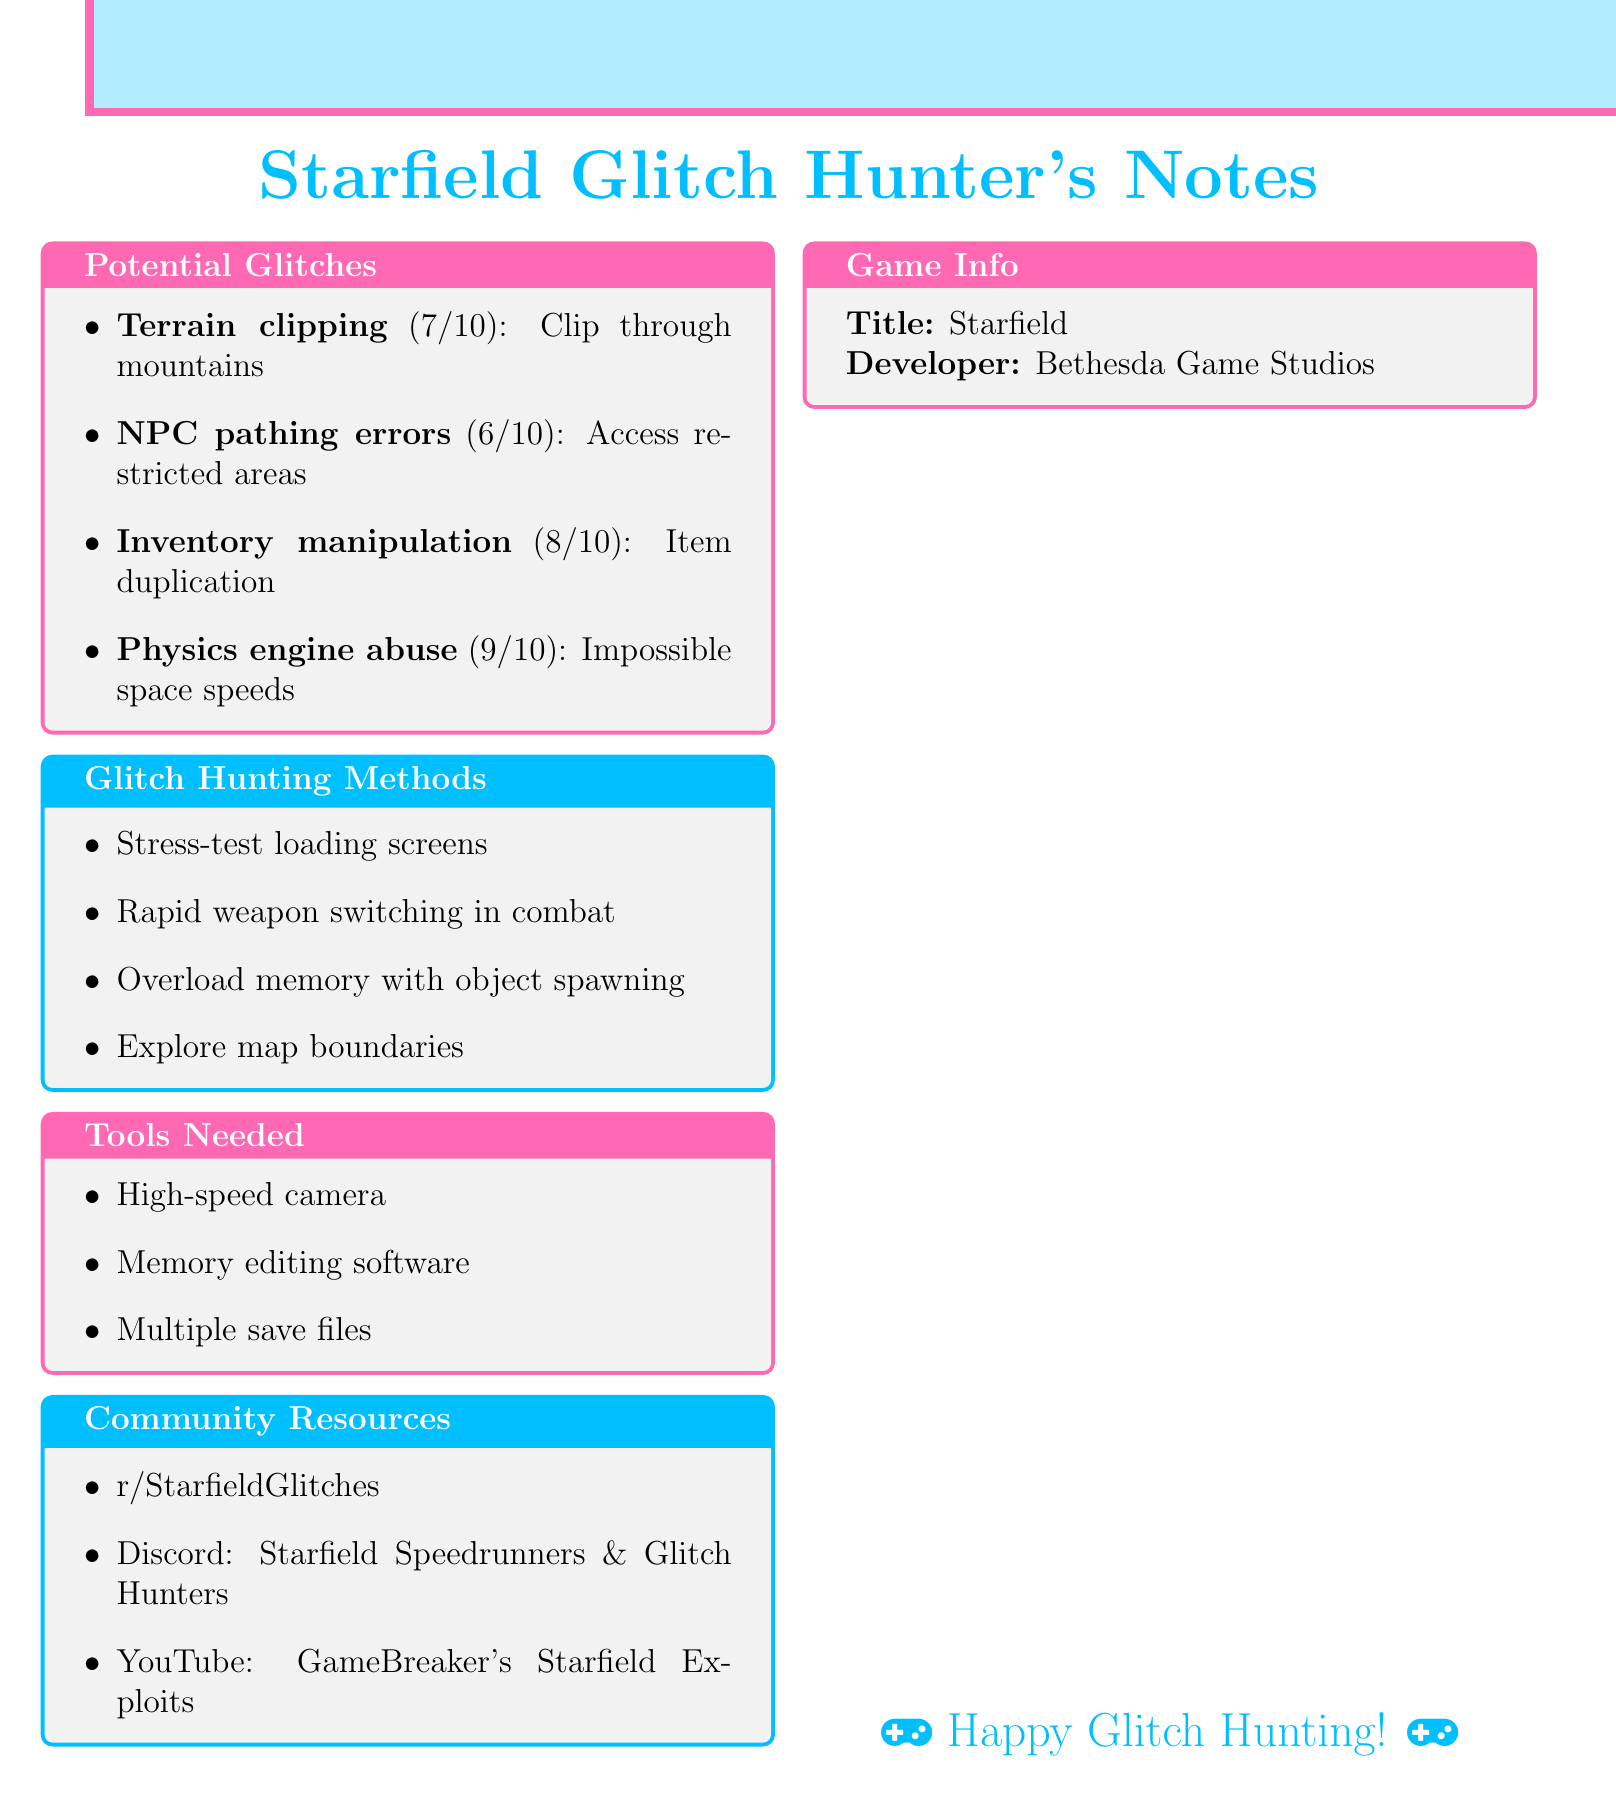what is the game title? The game title is mentioned at the beginning of the document as "Starfield".
Answer: Starfield who is the developer of the game? The developer of the game is explicitly stated in the document as "Bethesda Game Studios".
Answer: Bethesda Game Studios how many potential glitches are listed? The total number of potential glitches is counted from the list provided in the document.
Answer: 4 what is the exploitability rating for inventory manipulation? The exploitability rating is presented as a score next to each glitch in the document.
Answer: 8 which community resource is a subreddit? The document lists several community resources, and one of them is a subreddit mentioned explicitly.
Answer: r/StarfieldGlitches what method involves testing loading screens? The document lists various glitch hunting methods, one of which involves stress-testing loading screens.
Answer: Stress-test loading screens what tool is recommended for frame-by-frame analysis? The tools needed to assist with glitch hunting include a specific device for detailed observation mentioned in the document.
Answer: High-speed camera what is the potential exploit related to physics? The document describes an exploit related to the physics engine, highlighting its potential impact on gameplay.
Answer: Impossible space speeds how many glitch hunting methods are mentioned? The number of methods listed under the "Glitch Hunting Methods" section can be counted from the document.
Answer: 4 